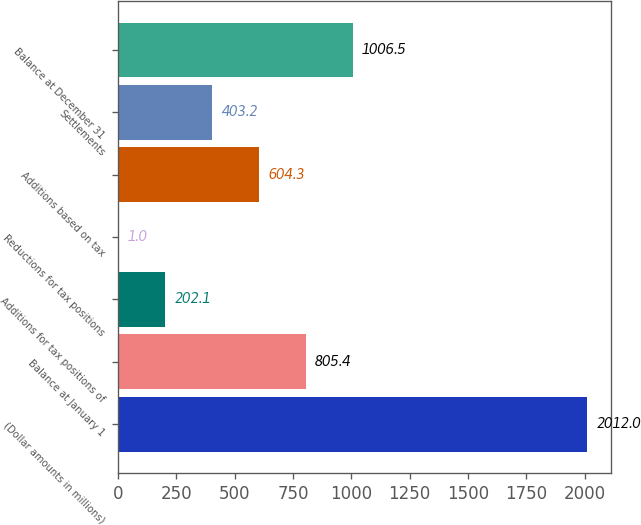Convert chart to OTSL. <chart><loc_0><loc_0><loc_500><loc_500><bar_chart><fcel>(Dollar amounts in millions)<fcel>Balance at January 1<fcel>Additions for tax positions of<fcel>Reductions for tax positions<fcel>Additions based on tax<fcel>Settlements<fcel>Balance at December 31<nl><fcel>2012<fcel>805.4<fcel>202.1<fcel>1<fcel>604.3<fcel>403.2<fcel>1006.5<nl></chart> 